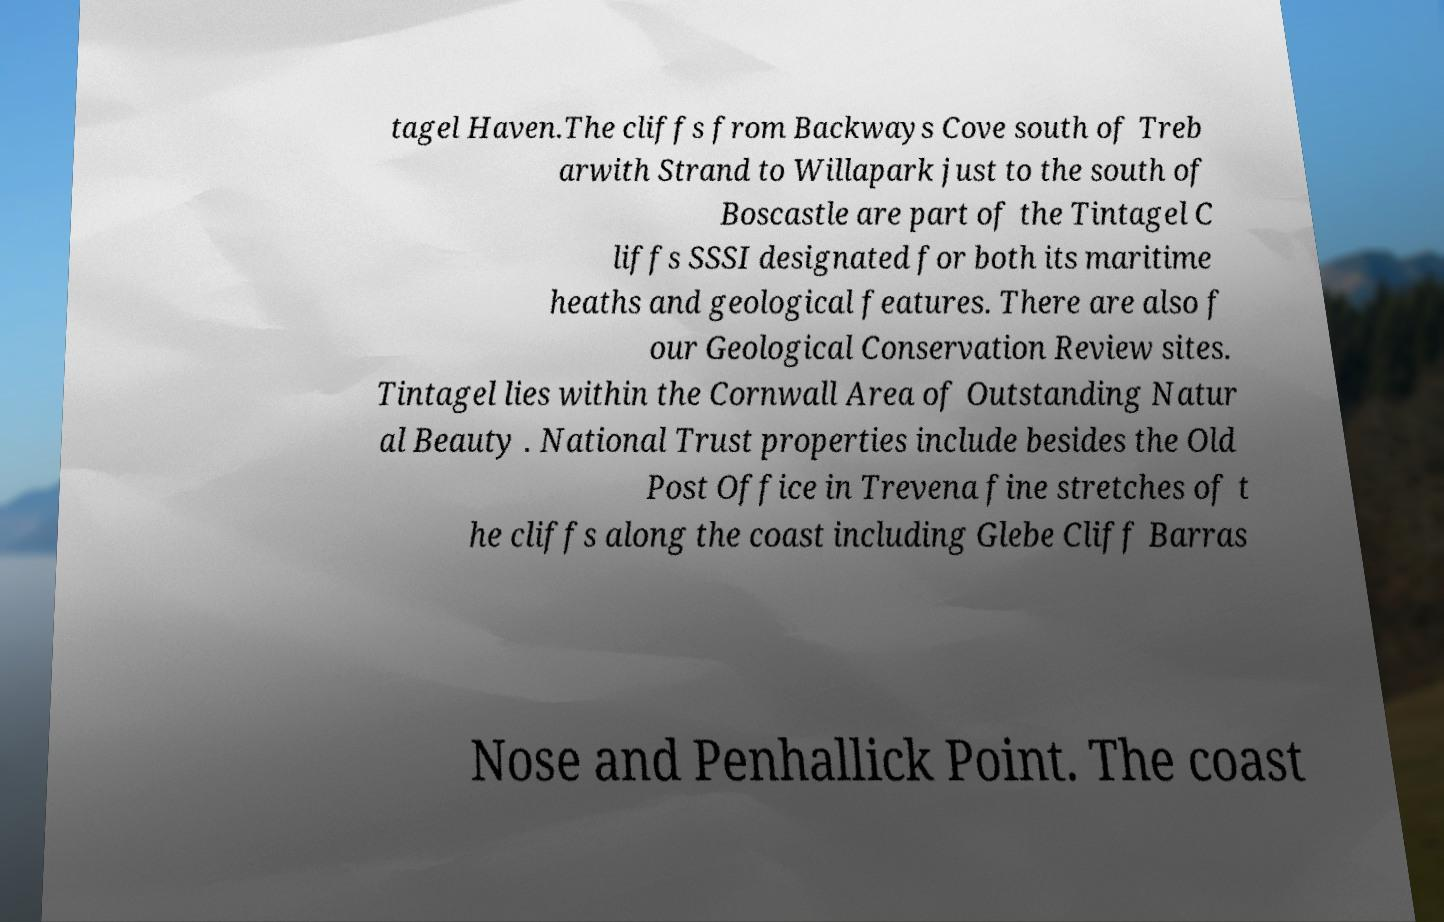Please read and relay the text visible in this image. What does it say? tagel Haven.The cliffs from Backways Cove south of Treb arwith Strand to Willapark just to the south of Boscastle are part of the Tintagel C liffs SSSI designated for both its maritime heaths and geological features. There are also f our Geological Conservation Review sites. Tintagel lies within the Cornwall Area of Outstanding Natur al Beauty . National Trust properties include besides the Old Post Office in Trevena fine stretches of t he cliffs along the coast including Glebe Cliff Barras Nose and Penhallick Point. The coast 